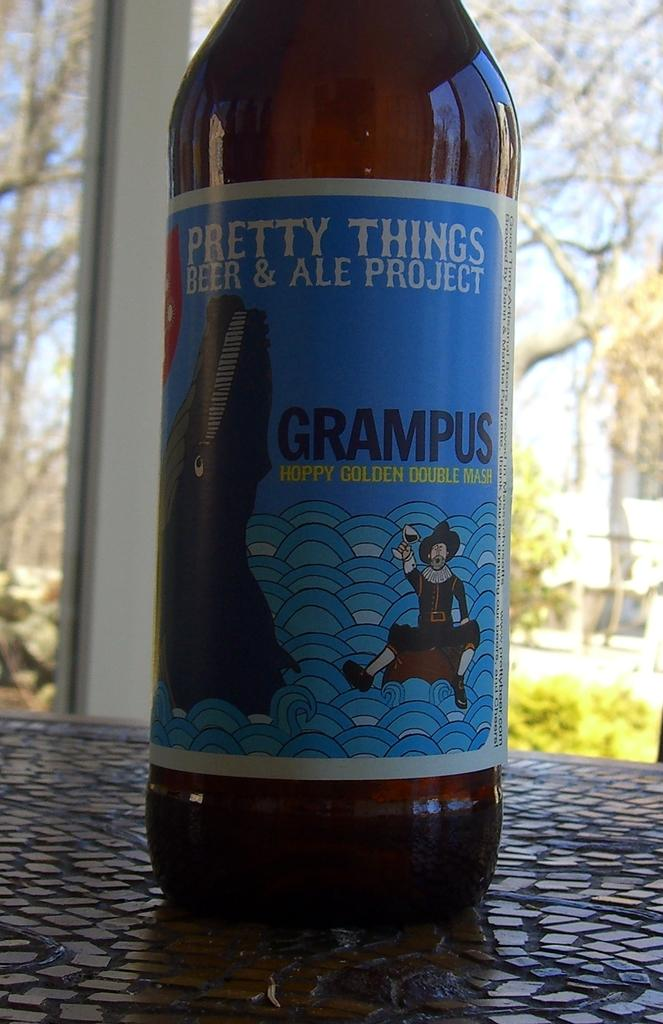<image>
Present a compact description of the photo's key features. The bottle of Grampus is described as a hoppy golden double mash. 